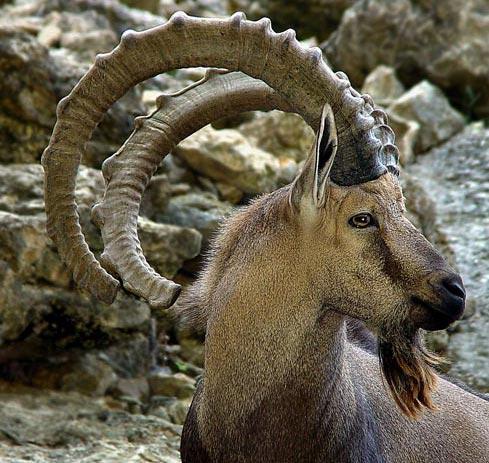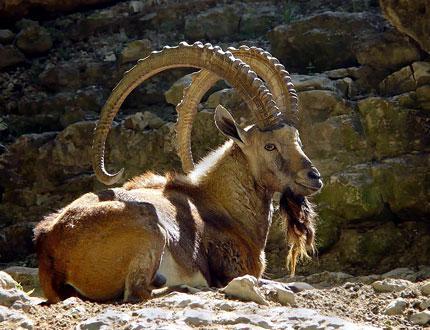The first image is the image on the left, the second image is the image on the right. Examine the images to the left and right. Is the description "One animal is laying down." accurate? Answer yes or no. Yes. 